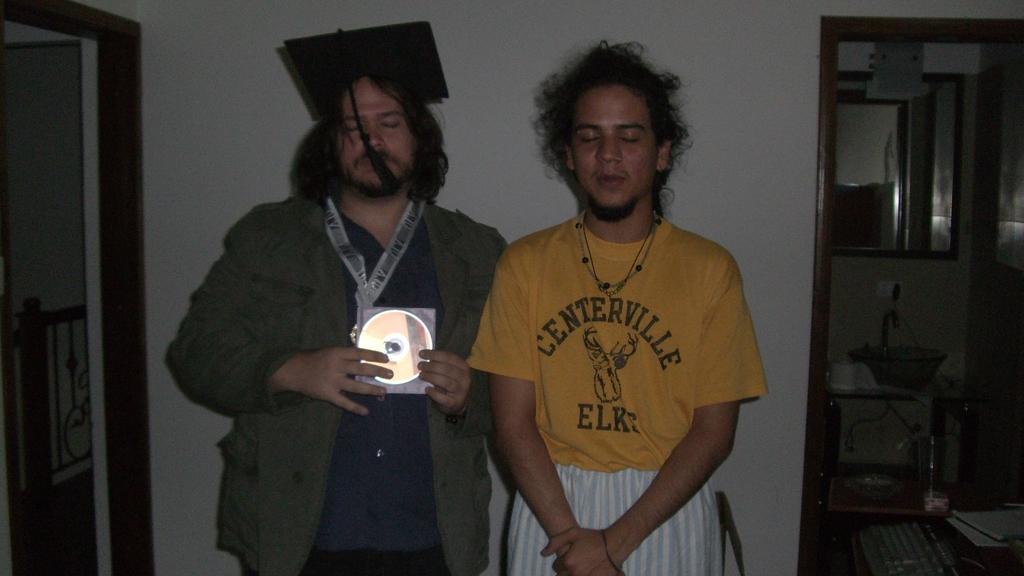How would you summarize this image in a sentence or two? In the foreground of this image, there are two men standing and one man is holding a CD and wearing a scholar cap. In the background, there is a wall, an entrance, mirror, few objects on the table. On the left, there is another entrance and the railing. 